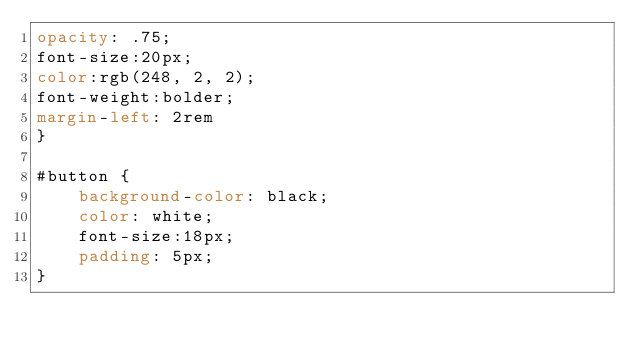<code> <loc_0><loc_0><loc_500><loc_500><_CSS_>opacity: .75;
font-size:20px;
color:rgb(248, 2, 2);
font-weight:bolder;
margin-left: 2rem
}

#button {
    background-color: black;
    color: white;
    font-size:18px;
    padding: 5px;
}</code> 